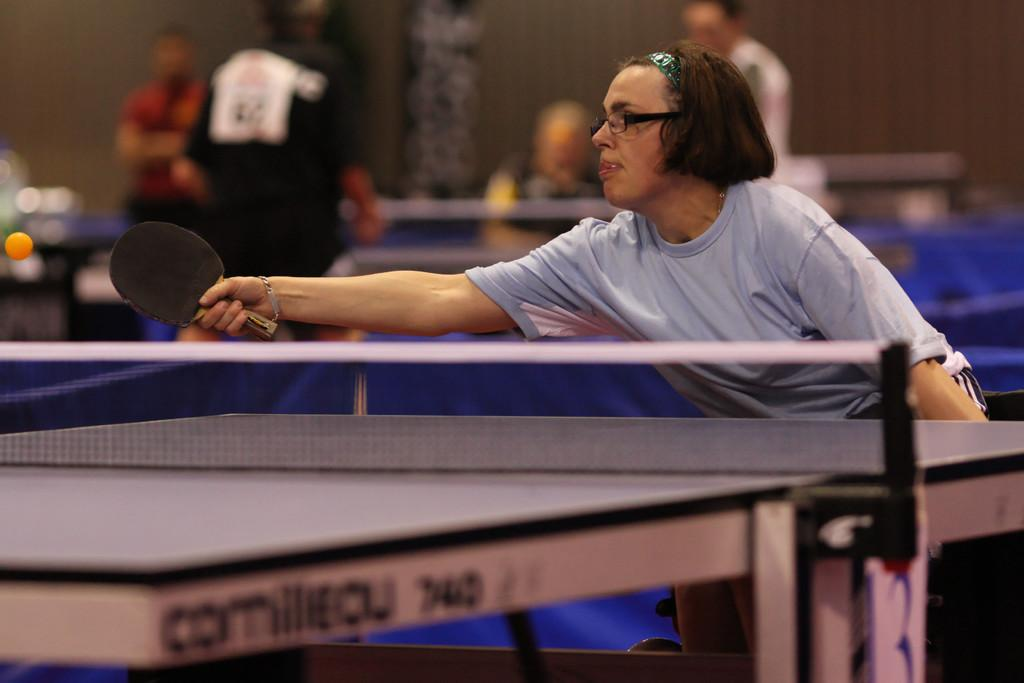Who is the main subject in the image? There is a woman in the image. What is the woman holding in the image? The woman is holding a table tennis racket. Can you describe the background of the image? The background of the image is blurry. What type of farming equipment can be seen in the image? There is no farming equipment present in the image. How many girls are visible in the image? There is only one person visible in the image, and it is a woman. 